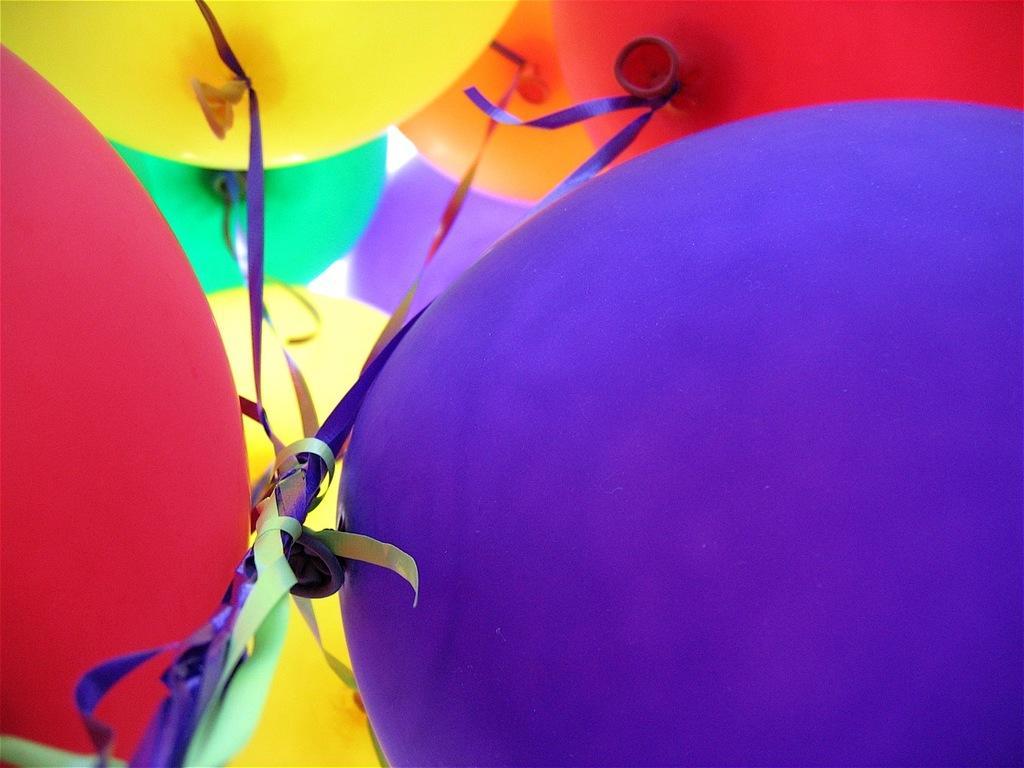Describe this image in one or two sentences. The picture of a balloons. There are many balloons. Blue balloon, Red balloon, Yellow balloon and Red balloon. which are tied with ribbons. 